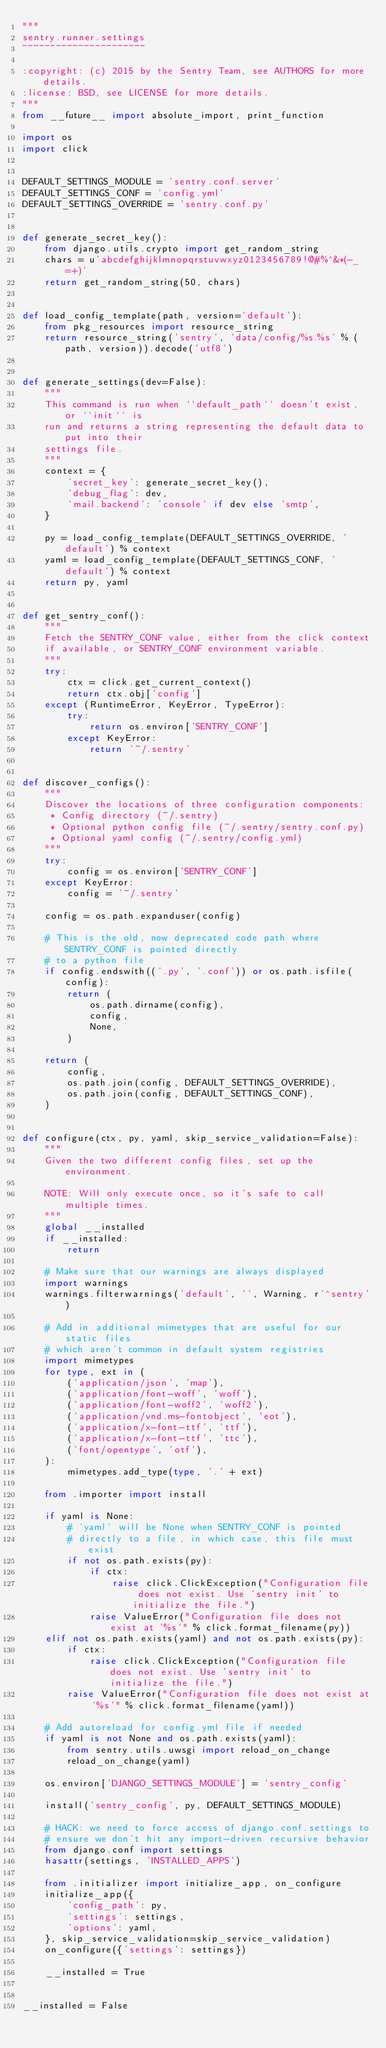Convert code to text. <code><loc_0><loc_0><loc_500><loc_500><_Python_>"""
sentry.runner.settings
~~~~~~~~~~~~~~~~~~~~~~

:copyright: (c) 2015 by the Sentry Team, see AUTHORS for more details.
:license: BSD, see LICENSE for more details.
"""
from __future__ import absolute_import, print_function

import os
import click


DEFAULT_SETTINGS_MODULE = 'sentry.conf.server'
DEFAULT_SETTINGS_CONF = 'config.yml'
DEFAULT_SETTINGS_OVERRIDE = 'sentry.conf.py'


def generate_secret_key():
    from django.utils.crypto import get_random_string
    chars = u'abcdefghijklmnopqrstuvwxyz0123456789!@#%^&*(-_=+)'
    return get_random_string(50, chars)


def load_config_template(path, version='default'):
    from pkg_resources import resource_string
    return resource_string('sentry', 'data/config/%s.%s' % (path, version)).decode('utf8')


def generate_settings(dev=False):
    """
    This command is run when ``default_path`` doesn't exist, or ``init`` is
    run and returns a string representing the default data to put into their
    settings file.
    """
    context = {
        'secret_key': generate_secret_key(),
        'debug_flag': dev,
        'mail.backend': 'console' if dev else 'smtp',
    }

    py = load_config_template(DEFAULT_SETTINGS_OVERRIDE, 'default') % context
    yaml = load_config_template(DEFAULT_SETTINGS_CONF, 'default') % context
    return py, yaml


def get_sentry_conf():
    """
    Fetch the SENTRY_CONF value, either from the click context
    if available, or SENTRY_CONF environment variable.
    """
    try:
        ctx = click.get_current_context()
        return ctx.obj['config']
    except (RuntimeError, KeyError, TypeError):
        try:
            return os.environ['SENTRY_CONF']
        except KeyError:
            return '~/.sentry'


def discover_configs():
    """
    Discover the locations of three configuration components:
     * Config directory (~/.sentry)
     * Optional python config file (~/.sentry/sentry.conf.py)
     * Optional yaml config (~/.sentry/config.yml)
    """
    try:
        config = os.environ['SENTRY_CONF']
    except KeyError:
        config = '~/.sentry'

    config = os.path.expanduser(config)

    # This is the old, now deprecated code path where SENTRY_CONF is pointed directly
    # to a python file
    if config.endswith(('.py', '.conf')) or os.path.isfile(config):
        return (
            os.path.dirname(config),
            config,
            None,
        )

    return (
        config,
        os.path.join(config, DEFAULT_SETTINGS_OVERRIDE),
        os.path.join(config, DEFAULT_SETTINGS_CONF),
    )


def configure(ctx, py, yaml, skip_service_validation=False):
    """
    Given the two different config files, set up the environment.

    NOTE: Will only execute once, so it's safe to call multiple times.
    """
    global __installed
    if __installed:
        return

    # Make sure that our warnings are always displayed
    import warnings
    warnings.filterwarnings('default', '', Warning, r'^sentry')

    # Add in additional mimetypes that are useful for our static files
    # which aren't common in default system registries
    import mimetypes
    for type, ext in (
        ('application/json', 'map'),
        ('application/font-woff', 'woff'),
        ('application/font-woff2', 'woff2'),
        ('application/vnd.ms-fontobject', 'eot'),
        ('application/x-font-ttf', 'ttf'),
        ('application/x-font-ttf', 'ttc'),
        ('font/opentype', 'otf'),
    ):
        mimetypes.add_type(type, '.' + ext)

    from .importer import install

    if yaml is None:
        # `yaml` will be None when SENTRY_CONF is pointed
        # directly to a file, in which case, this file must exist
        if not os.path.exists(py):
            if ctx:
                raise click.ClickException("Configuration file does not exist. Use 'sentry init' to initialize the file.")
            raise ValueError("Configuration file does not exist at '%s'" % click.format_filename(py))
    elif not os.path.exists(yaml) and not os.path.exists(py):
        if ctx:
            raise click.ClickException("Configuration file does not exist. Use 'sentry init' to initialize the file.")
        raise ValueError("Configuration file does not exist at '%s'" % click.format_filename(yaml))

    # Add autoreload for config.yml file if needed
    if yaml is not None and os.path.exists(yaml):
        from sentry.utils.uwsgi import reload_on_change
        reload_on_change(yaml)

    os.environ['DJANGO_SETTINGS_MODULE'] = 'sentry_config'

    install('sentry_config', py, DEFAULT_SETTINGS_MODULE)

    # HACK: we need to force access of django.conf.settings to
    # ensure we don't hit any import-driven recursive behavior
    from django.conf import settings
    hasattr(settings, 'INSTALLED_APPS')

    from .initializer import initialize_app, on_configure
    initialize_app({
        'config_path': py,
        'settings': settings,
        'options': yaml,
    }, skip_service_validation=skip_service_validation)
    on_configure({'settings': settings})

    __installed = True


__installed = False
</code> 